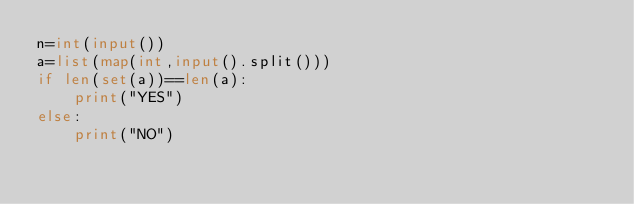Convert code to text. <code><loc_0><loc_0><loc_500><loc_500><_Python_>n=int(input())
a=list(map(int,input().split()))
if len(set(a))==len(a):
    print("YES")
else:
    print("NO")
</code> 